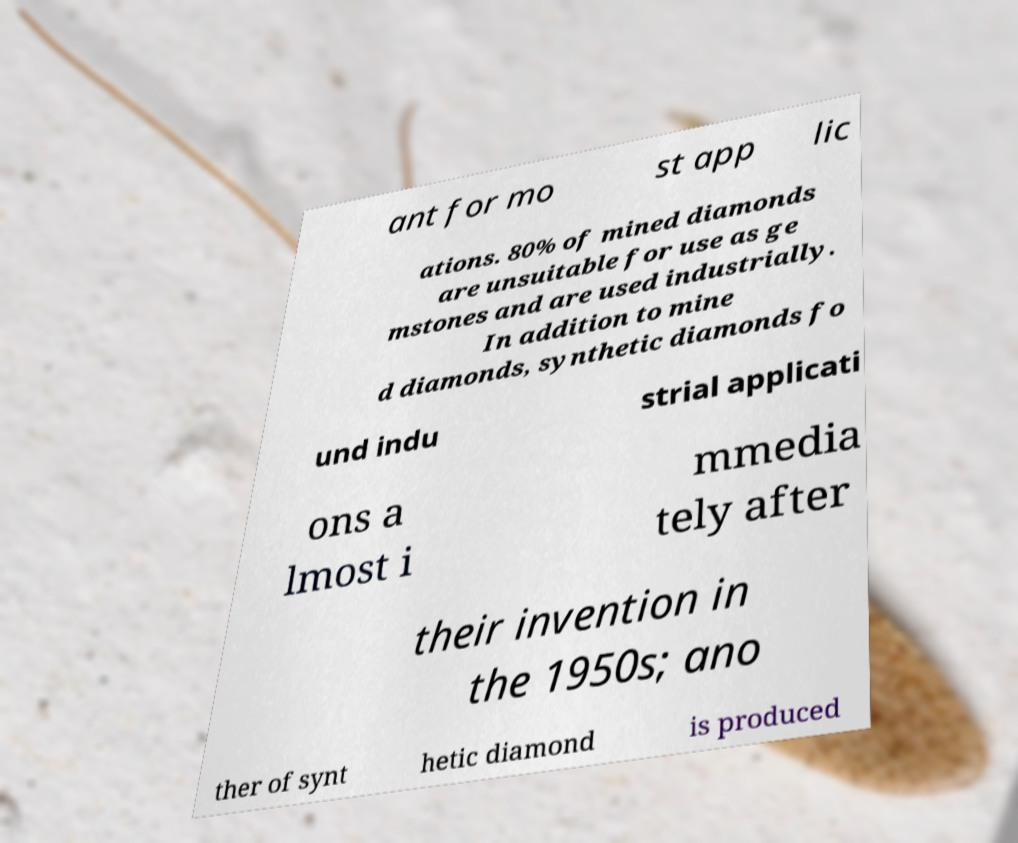There's text embedded in this image that I need extracted. Can you transcribe it verbatim? ant for mo st app lic ations. 80% of mined diamonds are unsuitable for use as ge mstones and are used industrially. In addition to mine d diamonds, synthetic diamonds fo und indu strial applicati ons a lmost i mmedia tely after their invention in the 1950s; ano ther of synt hetic diamond is produced 